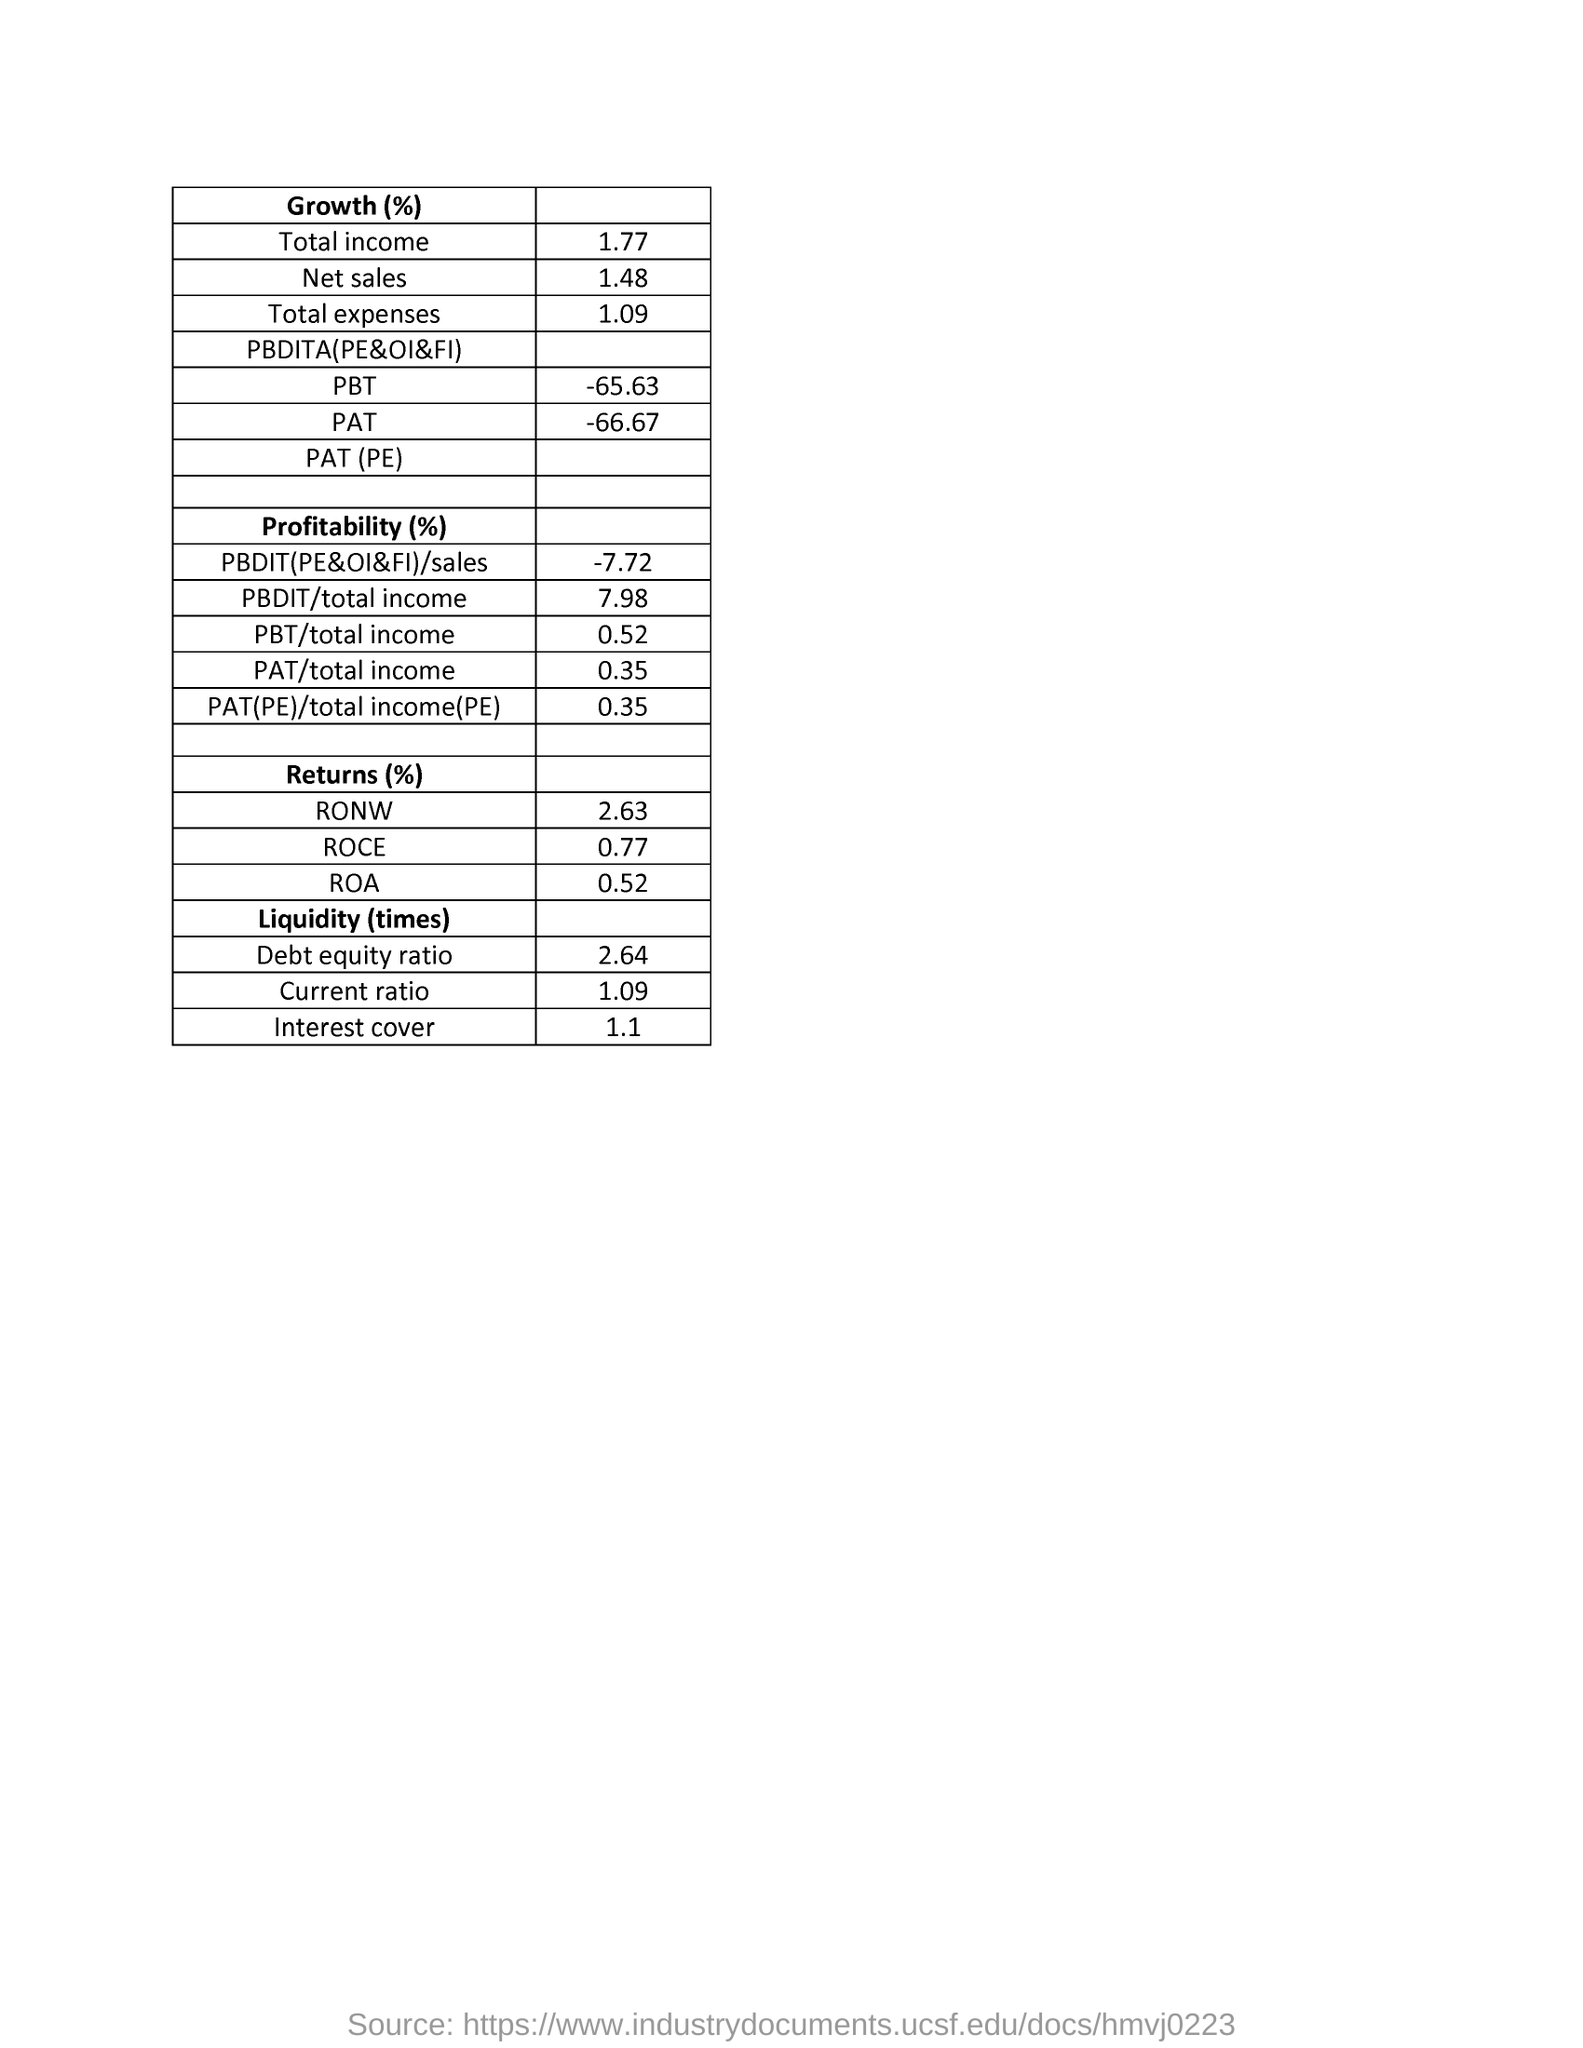What is the total expenses in growth (%)?
Provide a short and direct response. 1.09. What is the pat/total income in profitability?
Provide a short and direct response. 0.35%. What is the value of  roce in return?
Provide a succinct answer. 0.77%. What is the total income in the growth %?
Offer a terse response. 1.77. What is the pbt in growth (%)?
Your answer should be very brief. -65.63. What is the  pat of growth (%)?
Make the answer very short. -66.67. What is the roa in returns( %)?
Make the answer very short. 0.52. 